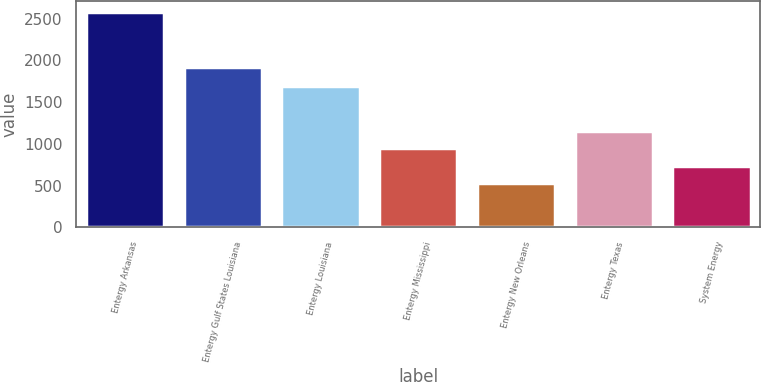<chart> <loc_0><loc_0><loc_500><loc_500><bar_chart><fcel>Entergy Arkansas<fcel>Entergy Gulf States Louisiana<fcel>Entergy Louisiana<fcel>Entergy Mississippi<fcel>Entergy New Orleans<fcel>Entergy Texas<fcel>System Energy<nl><fcel>2581<fcel>1923<fcel>1694<fcel>944.2<fcel>535<fcel>1148.8<fcel>739.6<nl></chart> 